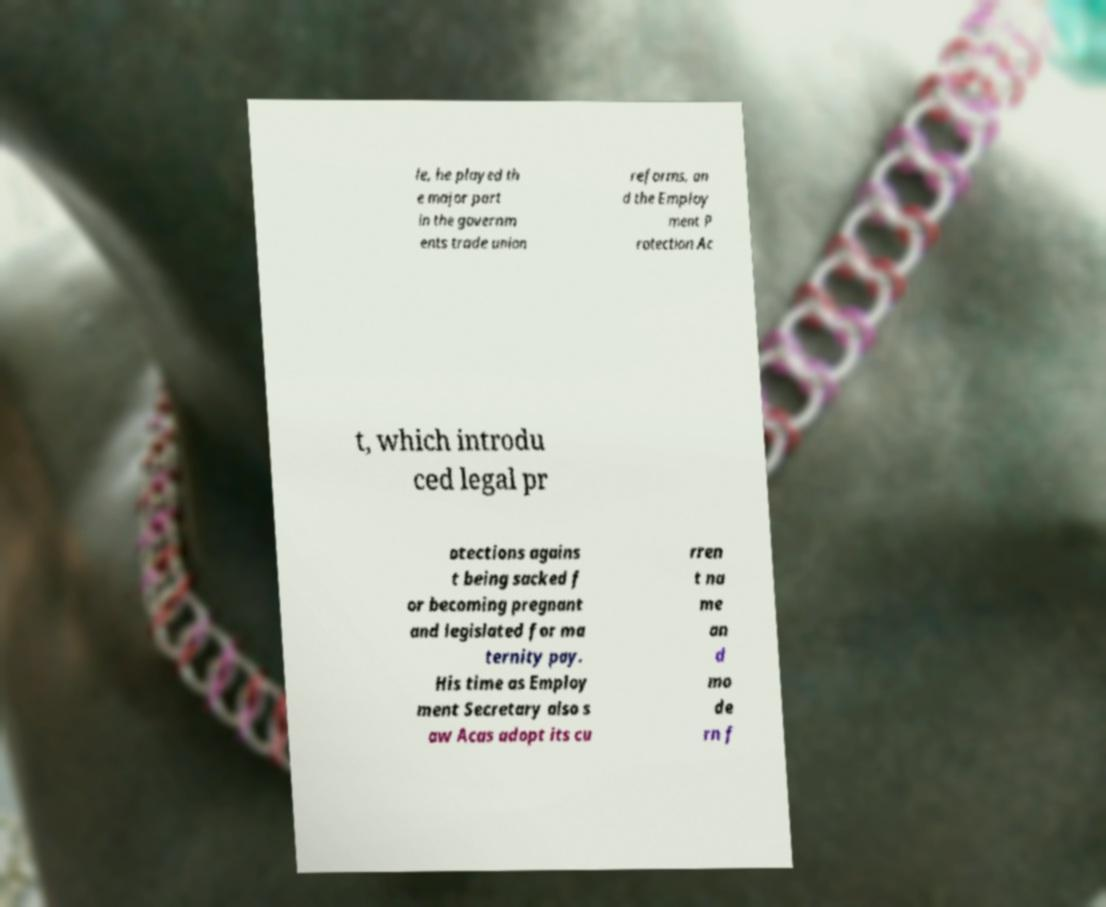Please identify and transcribe the text found in this image. le, he played th e major part in the governm ents trade union reforms, an d the Employ ment P rotection Ac t, which introdu ced legal pr otections agains t being sacked f or becoming pregnant and legislated for ma ternity pay. His time as Employ ment Secretary also s aw Acas adopt its cu rren t na me an d mo de rn f 